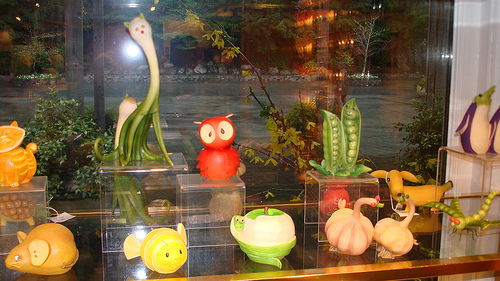<image>
Can you confirm if the toy is next to the peas? Yes. The toy is positioned adjacent to the peas, located nearby in the same general area. Where is the owl in relation to the fish? Is it to the left of the fish? No. The owl is not to the left of the fish. From this viewpoint, they have a different horizontal relationship. 